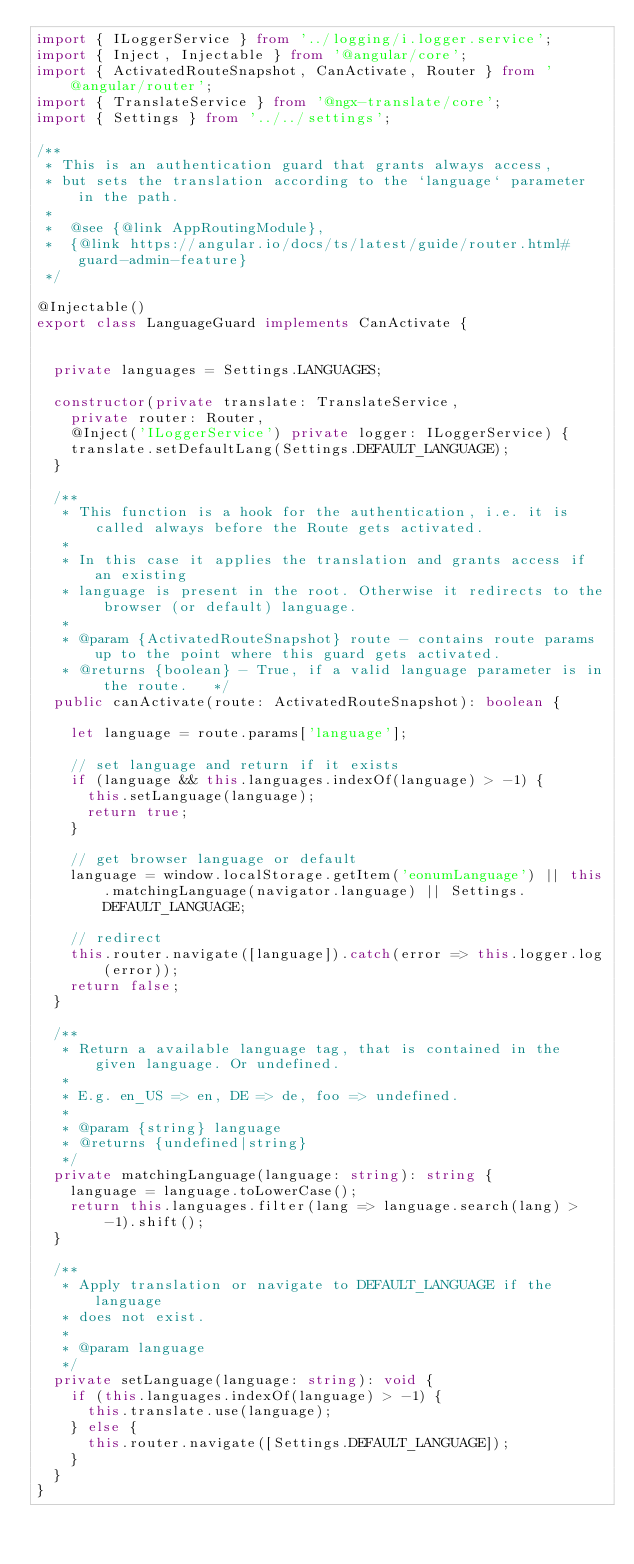<code> <loc_0><loc_0><loc_500><loc_500><_TypeScript_>import { ILoggerService } from '../logging/i.logger.service';
import { Inject, Injectable } from '@angular/core';
import { ActivatedRouteSnapshot, CanActivate, Router } from '@angular/router';
import { TranslateService } from '@ngx-translate/core';
import { Settings } from '../../settings';

/**
 * This is an authentication guard that grants always access,
 * but sets the translation according to the `language` parameter in the path.
 *
 *  @see {@link AppRoutingModule},
 *  {@link https://angular.io/docs/ts/latest/guide/router.html#guard-admin-feature}
 */

@Injectable()
export class LanguageGuard implements CanActivate {


  private languages = Settings.LANGUAGES;

  constructor(private translate: TranslateService,
    private router: Router,
    @Inject('ILoggerService') private logger: ILoggerService) {
    translate.setDefaultLang(Settings.DEFAULT_LANGUAGE);
  }

  /**
   * This function is a hook for the authentication, i.e. it is called always before the Route gets activated.
   *
   * In this case it applies the translation and grants access if an existing
   * language is present in the root. Otherwise it redirects to the browser (or default) language.
   *
   * @param {ActivatedRouteSnapshot} route - contains route params up to the point where this guard gets activated.
   * @returns {boolean} - True, if a valid language parameter is in the route.   */
  public canActivate(route: ActivatedRouteSnapshot): boolean {

    let language = route.params['language'];

    // set language and return if it exists
    if (language && this.languages.indexOf(language) > -1) {
      this.setLanguage(language);
      return true;
    }

    // get browser language or default
    language = window.localStorage.getItem('eonumLanguage') || this.matchingLanguage(navigator.language) || Settings.DEFAULT_LANGUAGE;

    // redirect
    this.router.navigate([language]).catch(error => this.logger.log(error));
    return false;
  }

  /**
   * Return a available language tag, that is contained in the given language. Or undefined.
   *
   * E.g. en_US => en, DE => de, foo => undefined.
   *
   * @param {string} language
   * @returns {undefined|string}
   */
  private matchingLanguage(language: string): string {
    language = language.toLowerCase();
    return this.languages.filter(lang => language.search(lang) > -1).shift();
  }

  /**
   * Apply translation or navigate to DEFAULT_LANGUAGE if the language
   * does not exist.
   *
   * @param language
   */
  private setLanguage(language: string): void {
    if (this.languages.indexOf(language) > -1) {
      this.translate.use(language);
    } else {
      this.router.navigate([Settings.DEFAULT_LANGUAGE]);
    }
  }
}

</code> 